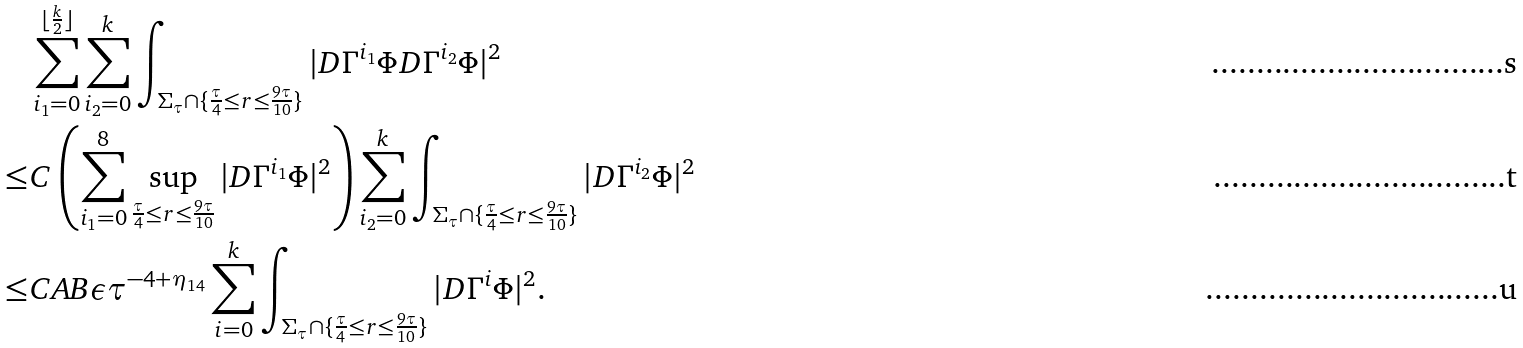<formula> <loc_0><loc_0><loc_500><loc_500>& \sum _ { i _ { 1 } = 0 } ^ { \lfloor \frac { k } { 2 } \rfloor } \sum _ { i _ { 2 } = 0 } ^ { k } \int _ { \Sigma _ { \tau } \cap \{ \frac { \tau } { 4 } \leq r \leq \frac { 9 \tau } { 1 0 } \} } | { D } \Gamma ^ { i _ { 1 } } \Phi D \Gamma ^ { i _ { 2 } } \Phi | ^ { 2 } \\ \leq & C \left ( \sum _ { i _ { 1 } = 0 } ^ { 8 } \sup _ { \frac { \tau } { 4 } \leq r \leq \frac { 9 \tau } { 1 0 } } | { D } \Gamma ^ { i _ { 1 } } \Phi | ^ { 2 } \right ) \sum _ { i _ { 2 } = 0 } ^ { k } \int _ { \Sigma _ { \tau } \cap \{ \frac { \tau } { 4 } \leq r \leq \frac { 9 \tau } { 1 0 } \} } | D \Gamma ^ { i _ { 2 } } \Phi | ^ { 2 } \\ \leq & C A B \epsilon \tau ^ { - 4 + \eta _ { 1 4 } } \sum _ { i = 0 } ^ { k } \int _ { \Sigma _ { \tau } \cap \{ \frac { \tau } { 4 } \leq r \leq \frac { 9 \tau } { 1 0 } \} } | D \Gamma ^ { i } \Phi | ^ { 2 } .</formula> 